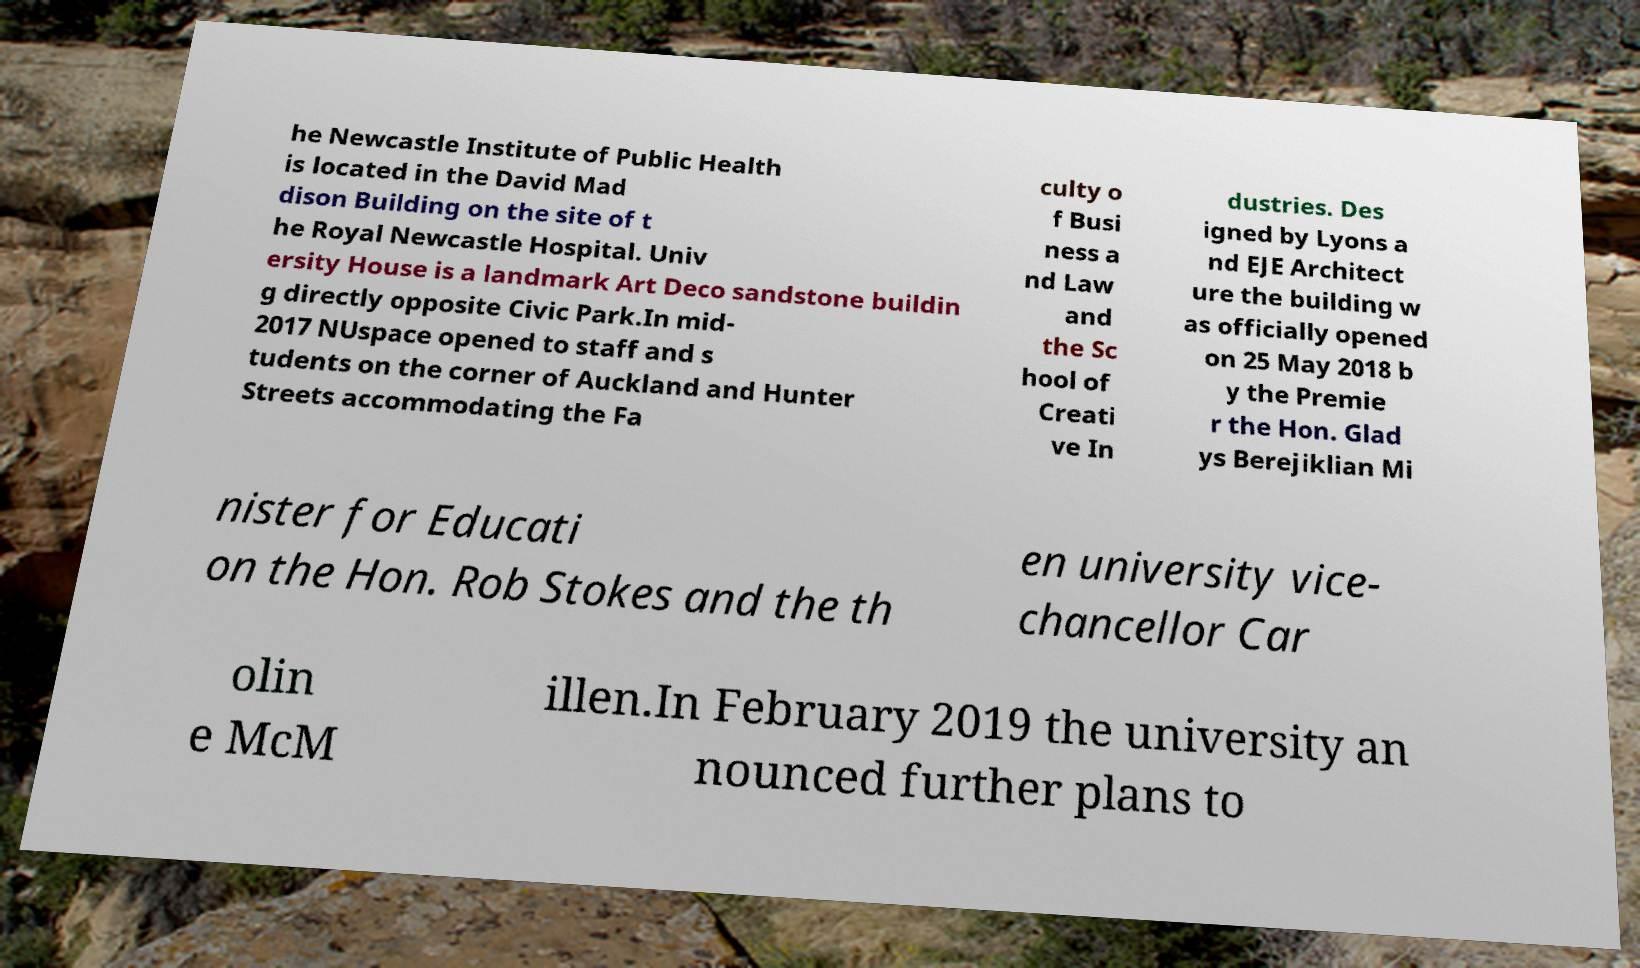There's text embedded in this image that I need extracted. Can you transcribe it verbatim? he Newcastle Institute of Public Health is located in the David Mad dison Building on the site of t he Royal Newcastle Hospital. Univ ersity House is a landmark Art Deco sandstone buildin g directly opposite Civic Park.In mid- 2017 NUspace opened to staff and s tudents on the corner of Auckland and Hunter Streets accommodating the Fa culty o f Busi ness a nd Law and the Sc hool of Creati ve In dustries. Des igned by Lyons a nd EJE Architect ure the building w as officially opened on 25 May 2018 b y the Premie r the Hon. Glad ys Berejiklian Mi nister for Educati on the Hon. Rob Stokes and the th en university vice- chancellor Car olin e McM illen.In February 2019 the university an nounced further plans to 